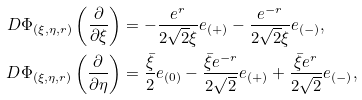<formula> <loc_0><loc_0><loc_500><loc_500>D \Phi _ { ( \xi , \eta , r ) } \left ( \frac { \partial } { \partial \xi } \right ) & = - \frac { e ^ { r } } { 2 \sqrt { 2 } \xi } e _ { ( + ) } - \frac { e ^ { - r } } { 2 \sqrt { 2 } \xi } e _ { ( - ) } , \\ D \Phi _ { ( \xi , \eta , r ) } \left ( \frac { \partial } { \partial \eta } \right ) & = \frac { \bar { \xi } } { 2 } e _ { ( 0 ) } - \frac { \bar { \xi } e ^ { - r } } { 2 \sqrt { 2 } } e _ { ( + ) } + \frac { \bar { \xi } e ^ { r } } { 2 \sqrt { 2 } } e _ { ( - ) } ,</formula> 